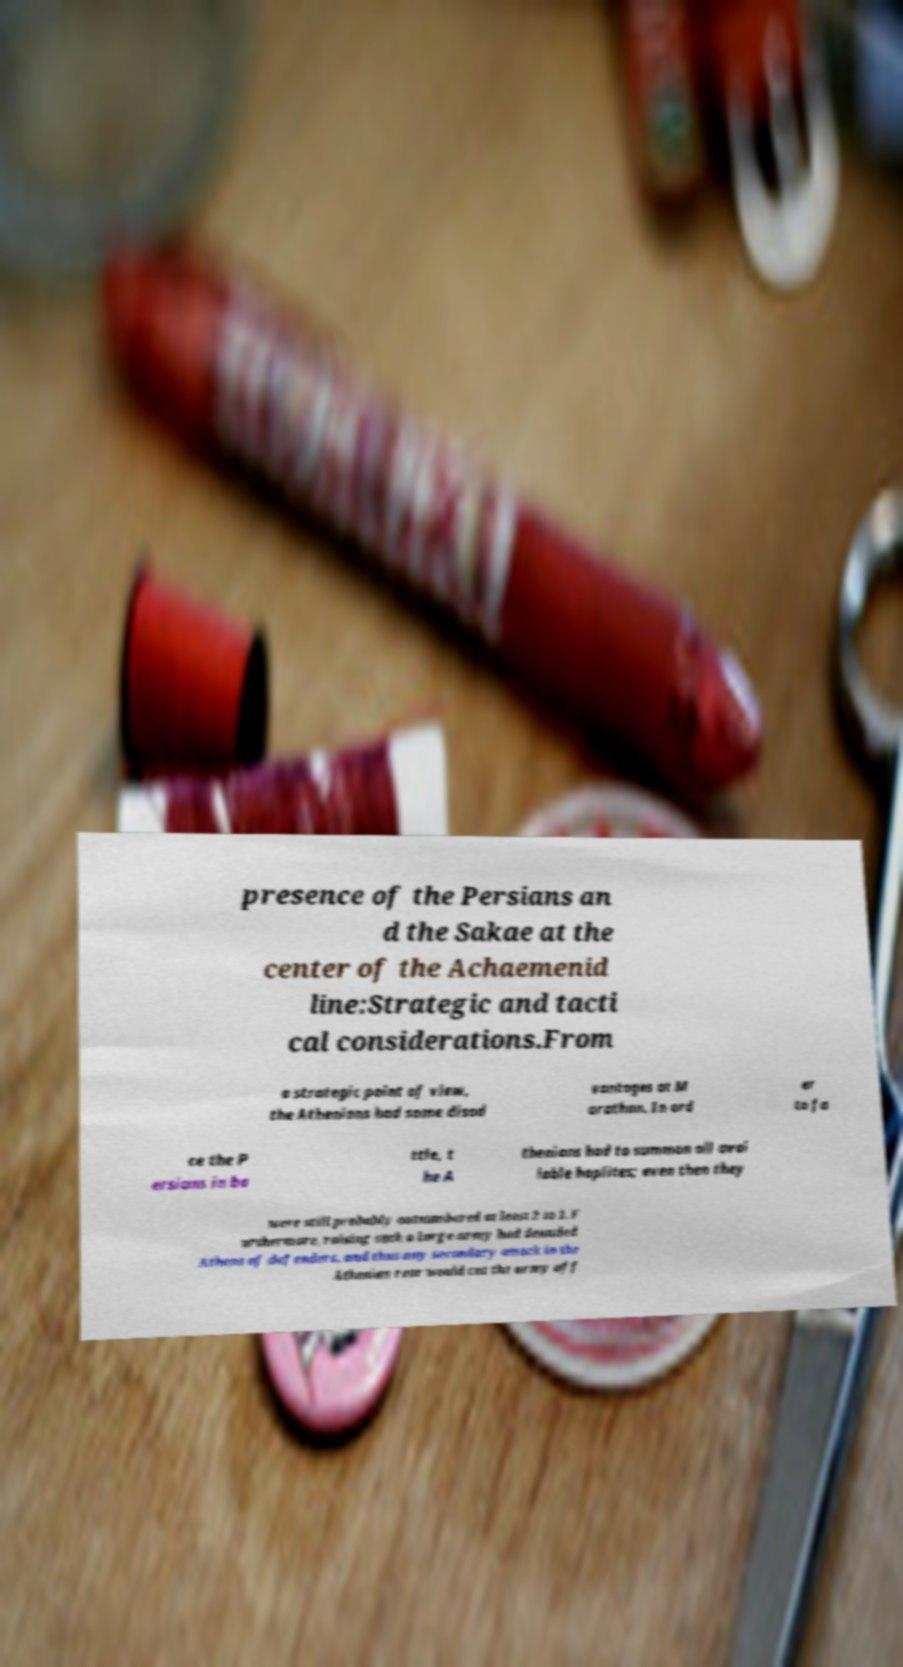Please identify and transcribe the text found in this image. presence of the Persians an d the Sakae at the center of the Achaemenid line:Strategic and tacti cal considerations.From a strategic point of view, the Athenians had some disad vantages at M arathon. In ord er to fa ce the P ersians in ba ttle, t he A thenians had to summon all avai lable hoplites; even then they were still probably outnumbered at least 2 to 1. F urthermore, raising such a large army had denuded Athens of defenders, and thus any secondary attack in the Athenian rear would cut the army off 